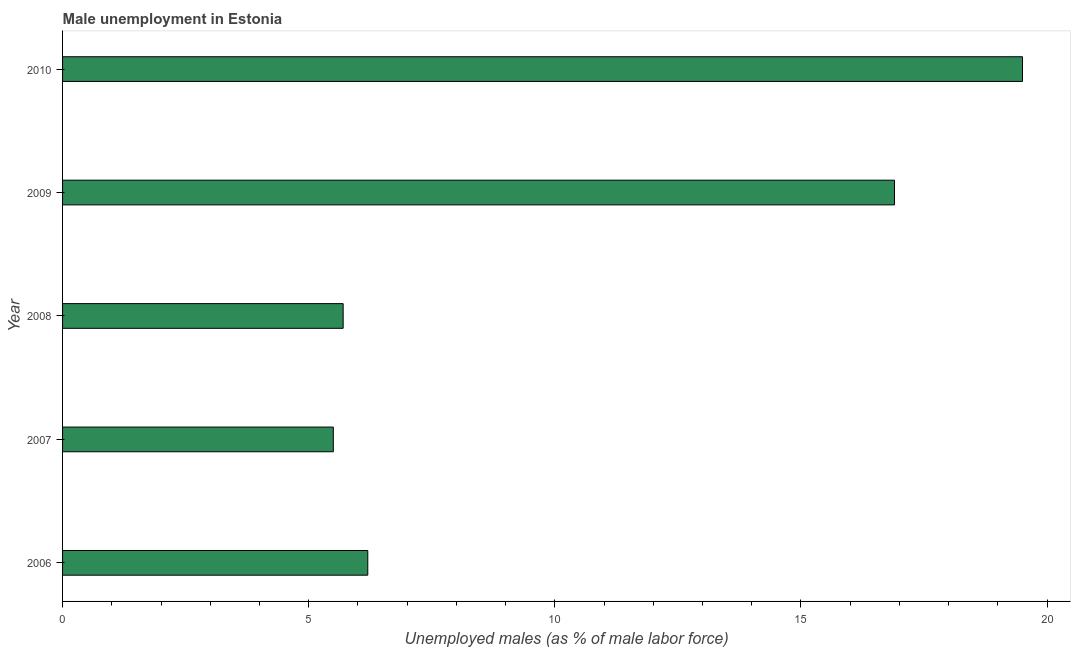Does the graph contain any zero values?
Ensure brevity in your answer.  No. Does the graph contain grids?
Keep it short and to the point. No. What is the title of the graph?
Ensure brevity in your answer.  Male unemployment in Estonia. What is the label or title of the X-axis?
Provide a short and direct response. Unemployed males (as % of male labor force). What is the label or title of the Y-axis?
Make the answer very short. Year. What is the unemployed males population in 2007?
Make the answer very short. 5.5. Across all years, what is the maximum unemployed males population?
Ensure brevity in your answer.  19.5. Across all years, what is the minimum unemployed males population?
Your response must be concise. 5.5. What is the sum of the unemployed males population?
Provide a succinct answer. 53.8. What is the difference between the unemployed males population in 2009 and 2010?
Your answer should be compact. -2.6. What is the average unemployed males population per year?
Your answer should be compact. 10.76. What is the median unemployed males population?
Keep it short and to the point. 6.2. What is the ratio of the unemployed males population in 2006 to that in 2007?
Your response must be concise. 1.13. Is the sum of the unemployed males population in 2006 and 2007 greater than the maximum unemployed males population across all years?
Offer a terse response. No. What is the difference between the highest and the lowest unemployed males population?
Your response must be concise. 14. Are all the bars in the graph horizontal?
Offer a terse response. Yes. How many years are there in the graph?
Provide a succinct answer. 5. What is the difference between two consecutive major ticks on the X-axis?
Provide a short and direct response. 5. Are the values on the major ticks of X-axis written in scientific E-notation?
Your answer should be very brief. No. What is the Unemployed males (as % of male labor force) of 2006?
Provide a succinct answer. 6.2. What is the Unemployed males (as % of male labor force) in 2007?
Give a very brief answer. 5.5. What is the Unemployed males (as % of male labor force) of 2008?
Offer a very short reply. 5.7. What is the Unemployed males (as % of male labor force) in 2009?
Your answer should be very brief. 16.9. What is the Unemployed males (as % of male labor force) of 2010?
Provide a short and direct response. 19.5. What is the difference between the Unemployed males (as % of male labor force) in 2006 and 2008?
Give a very brief answer. 0.5. What is the difference between the Unemployed males (as % of male labor force) in 2007 and 2010?
Provide a succinct answer. -14. What is the difference between the Unemployed males (as % of male labor force) in 2008 and 2010?
Offer a very short reply. -13.8. What is the ratio of the Unemployed males (as % of male labor force) in 2006 to that in 2007?
Offer a terse response. 1.13. What is the ratio of the Unemployed males (as % of male labor force) in 2006 to that in 2008?
Provide a short and direct response. 1.09. What is the ratio of the Unemployed males (as % of male labor force) in 2006 to that in 2009?
Provide a short and direct response. 0.37. What is the ratio of the Unemployed males (as % of male labor force) in 2006 to that in 2010?
Provide a succinct answer. 0.32. What is the ratio of the Unemployed males (as % of male labor force) in 2007 to that in 2009?
Make the answer very short. 0.33. What is the ratio of the Unemployed males (as % of male labor force) in 2007 to that in 2010?
Your response must be concise. 0.28. What is the ratio of the Unemployed males (as % of male labor force) in 2008 to that in 2009?
Your answer should be very brief. 0.34. What is the ratio of the Unemployed males (as % of male labor force) in 2008 to that in 2010?
Keep it short and to the point. 0.29. What is the ratio of the Unemployed males (as % of male labor force) in 2009 to that in 2010?
Ensure brevity in your answer.  0.87. 